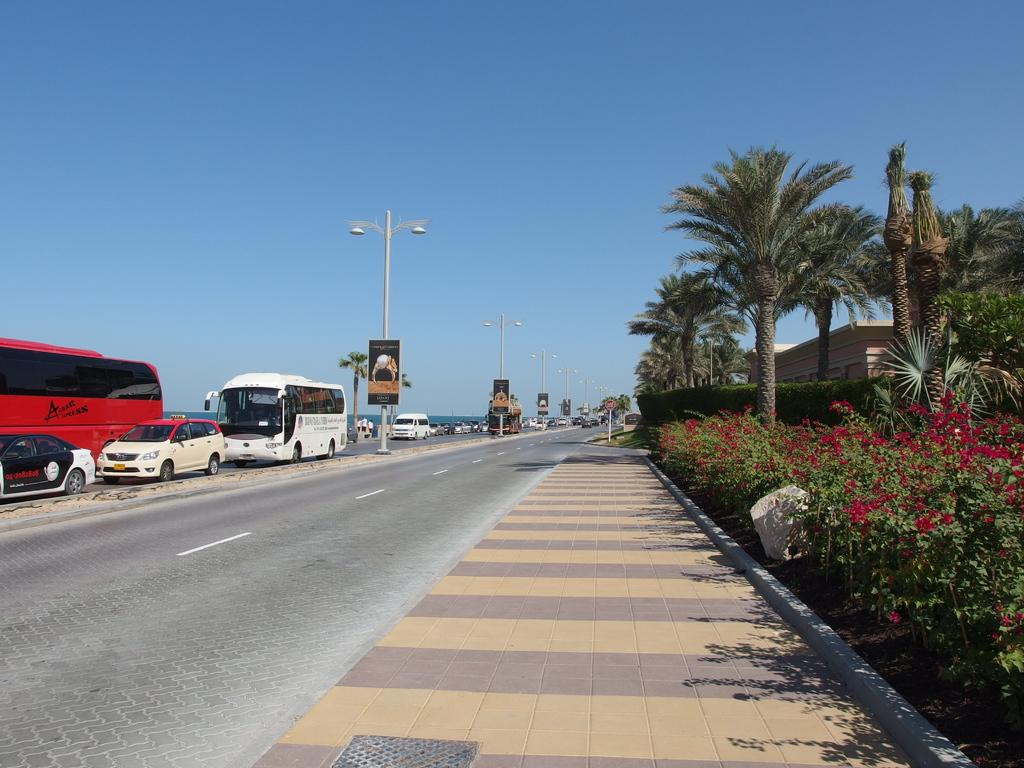What can be seen on the road in the image? There are vehicles on the road in the image. What is attached to the poles in the image? There are lights and boards attached to poles in the image. What type of plants are present in the image? There are plants with flowers in the image. What type of structure can be seen in the image? There is a house in the image. What else can be seen in the image besides the house? There are trees in the image. What is visible in the background of the image? The sky is visible in the background of the image. Where is the picture of the calendar located in the image? There is no picture of a calendar present in the image. What is the thumb doing in the image? There is no thumb present in the image. 